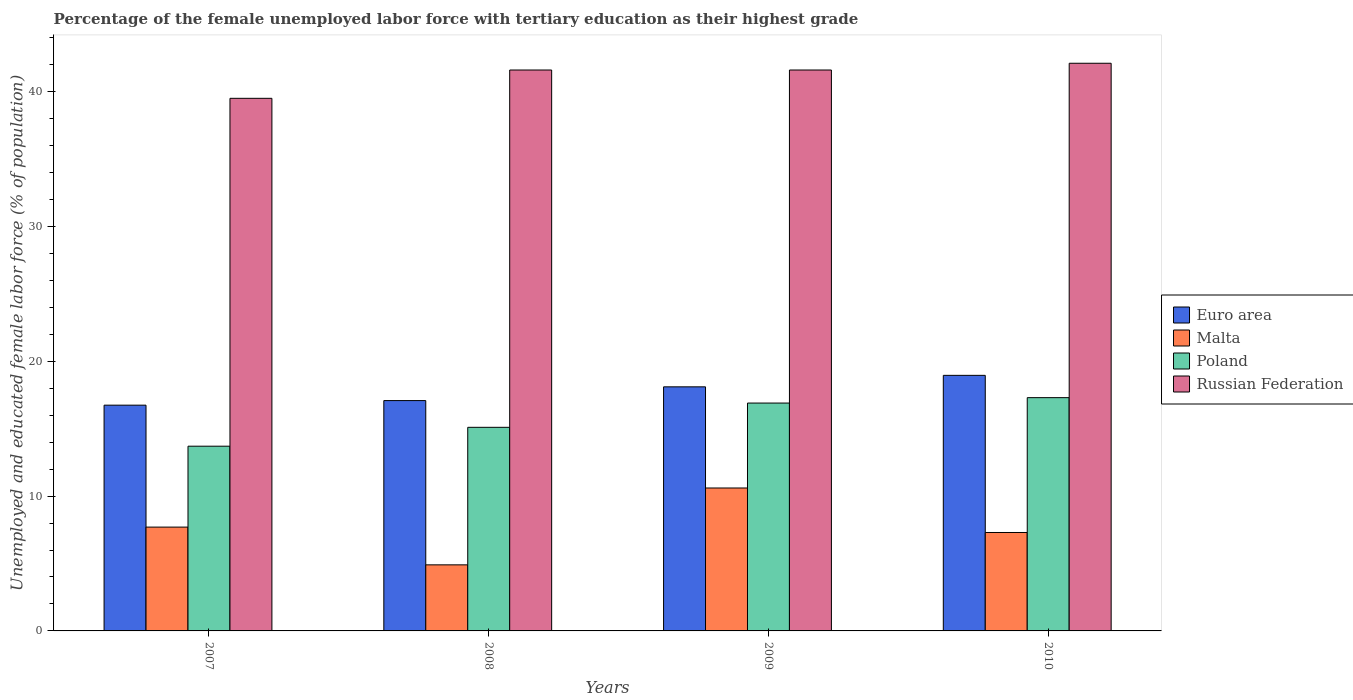How many different coloured bars are there?
Your answer should be very brief. 4. How many groups of bars are there?
Make the answer very short. 4. Are the number of bars per tick equal to the number of legend labels?
Offer a very short reply. Yes. Are the number of bars on each tick of the X-axis equal?
Ensure brevity in your answer.  Yes. What is the label of the 4th group of bars from the left?
Keep it short and to the point. 2010. What is the percentage of the unemployed female labor force with tertiary education in Euro area in 2007?
Offer a terse response. 16.74. Across all years, what is the maximum percentage of the unemployed female labor force with tertiary education in Malta?
Your answer should be very brief. 10.6. Across all years, what is the minimum percentage of the unemployed female labor force with tertiary education in Russian Federation?
Offer a very short reply. 39.5. In which year was the percentage of the unemployed female labor force with tertiary education in Russian Federation maximum?
Give a very brief answer. 2010. In which year was the percentage of the unemployed female labor force with tertiary education in Russian Federation minimum?
Make the answer very short. 2007. What is the total percentage of the unemployed female labor force with tertiary education in Russian Federation in the graph?
Your answer should be very brief. 164.8. What is the difference between the percentage of the unemployed female labor force with tertiary education in Malta in 2007 and that in 2010?
Your answer should be very brief. 0.4. What is the difference between the percentage of the unemployed female labor force with tertiary education in Euro area in 2007 and the percentage of the unemployed female labor force with tertiary education in Poland in 2010?
Offer a very short reply. -0.56. What is the average percentage of the unemployed female labor force with tertiary education in Malta per year?
Your answer should be compact. 7.63. In the year 2010, what is the difference between the percentage of the unemployed female labor force with tertiary education in Poland and percentage of the unemployed female labor force with tertiary education in Russian Federation?
Your response must be concise. -24.8. In how many years, is the percentage of the unemployed female labor force with tertiary education in Malta greater than 42 %?
Provide a succinct answer. 0. What is the ratio of the percentage of the unemployed female labor force with tertiary education in Russian Federation in 2009 to that in 2010?
Offer a very short reply. 0.99. What is the difference between the highest and the second highest percentage of the unemployed female labor force with tertiary education in Poland?
Your answer should be very brief. 0.4. What is the difference between the highest and the lowest percentage of the unemployed female labor force with tertiary education in Euro area?
Ensure brevity in your answer.  2.21. Is it the case that in every year, the sum of the percentage of the unemployed female labor force with tertiary education in Malta and percentage of the unemployed female labor force with tertiary education in Euro area is greater than the sum of percentage of the unemployed female labor force with tertiary education in Poland and percentage of the unemployed female labor force with tertiary education in Russian Federation?
Provide a short and direct response. No. What does the 3rd bar from the left in 2009 represents?
Your answer should be compact. Poland. What does the 3rd bar from the right in 2009 represents?
Keep it short and to the point. Malta. Is it the case that in every year, the sum of the percentage of the unemployed female labor force with tertiary education in Poland and percentage of the unemployed female labor force with tertiary education in Euro area is greater than the percentage of the unemployed female labor force with tertiary education in Malta?
Make the answer very short. Yes. How many bars are there?
Your response must be concise. 16. How many years are there in the graph?
Your answer should be compact. 4. Does the graph contain any zero values?
Make the answer very short. No. How many legend labels are there?
Your answer should be very brief. 4. What is the title of the graph?
Your response must be concise. Percentage of the female unemployed labor force with tertiary education as their highest grade. What is the label or title of the Y-axis?
Provide a short and direct response. Unemployed and educated female labor force (% of population). What is the Unemployed and educated female labor force (% of population) in Euro area in 2007?
Ensure brevity in your answer.  16.74. What is the Unemployed and educated female labor force (% of population) in Malta in 2007?
Provide a short and direct response. 7.7. What is the Unemployed and educated female labor force (% of population) of Poland in 2007?
Keep it short and to the point. 13.7. What is the Unemployed and educated female labor force (% of population) in Russian Federation in 2007?
Offer a very short reply. 39.5. What is the Unemployed and educated female labor force (% of population) in Euro area in 2008?
Your response must be concise. 17.08. What is the Unemployed and educated female labor force (% of population) in Malta in 2008?
Offer a terse response. 4.9. What is the Unemployed and educated female labor force (% of population) of Poland in 2008?
Keep it short and to the point. 15.1. What is the Unemployed and educated female labor force (% of population) in Russian Federation in 2008?
Your response must be concise. 41.6. What is the Unemployed and educated female labor force (% of population) in Euro area in 2009?
Your answer should be very brief. 18.1. What is the Unemployed and educated female labor force (% of population) in Malta in 2009?
Your answer should be very brief. 10.6. What is the Unemployed and educated female labor force (% of population) of Poland in 2009?
Your answer should be very brief. 16.9. What is the Unemployed and educated female labor force (% of population) in Russian Federation in 2009?
Provide a short and direct response. 41.6. What is the Unemployed and educated female labor force (% of population) in Euro area in 2010?
Offer a very short reply. 18.95. What is the Unemployed and educated female labor force (% of population) in Malta in 2010?
Ensure brevity in your answer.  7.3. What is the Unemployed and educated female labor force (% of population) of Poland in 2010?
Provide a succinct answer. 17.3. What is the Unemployed and educated female labor force (% of population) of Russian Federation in 2010?
Ensure brevity in your answer.  42.1. Across all years, what is the maximum Unemployed and educated female labor force (% of population) in Euro area?
Keep it short and to the point. 18.95. Across all years, what is the maximum Unemployed and educated female labor force (% of population) in Malta?
Provide a short and direct response. 10.6. Across all years, what is the maximum Unemployed and educated female labor force (% of population) of Poland?
Your answer should be very brief. 17.3. Across all years, what is the maximum Unemployed and educated female labor force (% of population) in Russian Federation?
Your response must be concise. 42.1. Across all years, what is the minimum Unemployed and educated female labor force (% of population) in Euro area?
Your answer should be compact. 16.74. Across all years, what is the minimum Unemployed and educated female labor force (% of population) in Malta?
Provide a short and direct response. 4.9. Across all years, what is the minimum Unemployed and educated female labor force (% of population) in Poland?
Provide a short and direct response. 13.7. Across all years, what is the minimum Unemployed and educated female labor force (% of population) in Russian Federation?
Your answer should be very brief. 39.5. What is the total Unemployed and educated female labor force (% of population) of Euro area in the graph?
Provide a succinct answer. 70.88. What is the total Unemployed and educated female labor force (% of population) in Malta in the graph?
Ensure brevity in your answer.  30.5. What is the total Unemployed and educated female labor force (% of population) in Poland in the graph?
Your answer should be very brief. 63. What is the total Unemployed and educated female labor force (% of population) of Russian Federation in the graph?
Provide a short and direct response. 164.8. What is the difference between the Unemployed and educated female labor force (% of population) of Euro area in 2007 and that in 2008?
Your response must be concise. -0.34. What is the difference between the Unemployed and educated female labor force (% of population) of Poland in 2007 and that in 2008?
Your response must be concise. -1.4. What is the difference between the Unemployed and educated female labor force (% of population) of Russian Federation in 2007 and that in 2008?
Your response must be concise. -2.1. What is the difference between the Unemployed and educated female labor force (% of population) of Euro area in 2007 and that in 2009?
Ensure brevity in your answer.  -1.36. What is the difference between the Unemployed and educated female labor force (% of population) in Poland in 2007 and that in 2009?
Give a very brief answer. -3.2. What is the difference between the Unemployed and educated female labor force (% of population) in Euro area in 2007 and that in 2010?
Offer a very short reply. -2.21. What is the difference between the Unemployed and educated female labor force (% of population) in Russian Federation in 2007 and that in 2010?
Ensure brevity in your answer.  -2.6. What is the difference between the Unemployed and educated female labor force (% of population) in Euro area in 2008 and that in 2009?
Provide a short and direct response. -1.02. What is the difference between the Unemployed and educated female labor force (% of population) in Malta in 2008 and that in 2009?
Your answer should be very brief. -5.7. What is the difference between the Unemployed and educated female labor force (% of population) of Poland in 2008 and that in 2009?
Your answer should be compact. -1.8. What is the difference between the Unemployed and educated female labor force (% of population) of Euro area in 2008 and that in 2010?
Keep it short and to the point. -1.87. What is the difference between the Unemployed and educated female labor force (% of population) of Malta in 2008 and that in 2010?
Give a very brief answer. -2.4. What is the difference between the Unemployed and educated female labor force (% of population) of Poland in 2008 and that in 2010?
Your response must be concise. -2.2. What is the difference between the Unemployed and educated female labor force (% of population) of Euro area in 2009 and that in 2010?
Give a very brief answer. -0.85. What is the difference between the Unemployed and educated female labor force (% of population) in Poland in 2009 and that in 2010?
Your response must be concise. -0.4. What is the difference between the Unemployed and educated female labor force (% of population) in Euro area in 2007 and the Unemployed and educated female labor force (% of population) in Malta in 2008?
Provide a short and direct response. 11.84. What is the difference between the Unemployed and educated female labor force (% of population) in Euro area in 2007 and the Unemployed and educated female labor force (% of population) in Poland in 2008?
Your answer should be compact. 1.64. What is the difference between the Unemployed and educated female labor force (% of population) of Euro area in 2007 and the Unemployed and educated female labor force (% of population) of Russian Federation in 2008?
Keep it short and to the point. -24.86. What is the difference between the Unemployed and educated female labor force (% of population) of Malta in 2007 and the Unemployed and educated female labor force (% of population) of Russian Federation in 2008?
Provide a succinct answer. -33.9. What is the difference between the Unemployed and educated female labor force (% of population) of Poland in 2007 and the Unemployed and educated female labor force (% of population) of Russian Federation in 2008?
Provide a short and direct response. -27.9. What is the difference between the Unemployed and educated female labor force (% of population) in Euro area in 2007 and the Unemployed and educated female labor force (% of population) in Malta in 2009?
Provide a short and direct response. 6.14. What is the difference between the Unemployed and educated female labor force (% of population) in Euro area in 2007 and the Unemployed and educated female labor force (% of population) in Poland in 2009?
Offer a very short reply. -0.16. What is the difference between the Unemployed and educated female labor force (% of population) in Euro area in 2007 and the Unemployed and educated female labor force (% of population) in Russian Federation in 2009?
Offer a terse response. -24.86. What is the difference between the Unemployed and educated female labor force (% of population) of Malta in 2007 and the Unemployed and educated female labor force (% of population) of Russian Federation in 2009?
Make the answer very short. -33.9. What is the difference between the Unemployed and educated female labor force (% of population) of Poland in 2007 and the Unemployed and educated female labor force (% of population) of Russian Federation in 2009?
Your response must be concise. -27.9. What is the difference between the Unemployed and educated female labor force (% of population) of Euro area in 2007 and the Unemployed and educated female labor force (% of population) of Malta in 2010?
Offer a terse response. 9.44. What is the difference between the Unemployed and educated female labor force (% of population) of Euro area in 2007 and the Unemployed and educated female labor force (% of population) of Poland in 2010?
Ensure brevity in your answer.  -0.56. What is the difference between the Unemployed and educated female labor force (% of population) of Euro area in 2007 and the Unemployed and educated female labor force (% of population) of Russian Federation in 2010?
Provide a short and direct response. -25.36. What is the difference between the Unemployed and educated female labor force (% of population) of Malta in 2007 and the Unemployed and educated female labor force (% of population) of Poland in 2010?
Make the answer very short. -9.6. What is the difference between the Unemployed and educated female labor force (% of population) in Malta in 2007 and the Unemployed and educated female labor force (% of population) in Russian Federation in 2010?
Your answer should be compact. -34.4. What is the difference between the Unemployed and educated female labor force (% of population) in Poland in 2007 and the Unemployed and educated female labor force (% of population) in Russian Federation in 2010?
Keep it short and to the point. -28.4. What is the difference between the Unemployed and educated female labor force (% of population) of Euro area in 2008 and the Unemployed and educated female labor force (% of population) of Malta in 2009?
Ensure brevity in your answer.  6.48. What is the difference between the Unemployed and educated female labor force (% of population) of Euro area in 2008 and the Unemployed and educated female labor force (% of population) of Poland in 2009?
Offer a very short reply. 0.18. What is the difference between the Unemployed and educated female labor force (% of population) in Euro area in 2008 and the Unemployed and educated female labor force (% of population) in Russian Federation in 2009?
Your answer should be compact. -24.52. What is the difference between the Unemployed and educated female labor force (% of population) of Malta in 2008 and the Unemployed and educated female labor force (% of population) of Poland in 2009?
Ensure brevity in your answer.  -12. What is the difference between the Unemployed and educated female labor force (% of population) of Malta in 2008 and the Unemployed and educated female labor force (% of population) of Russian Federation in 2009?
Your answer should be very brief. -36.7. What is the difference between the Unemployed and educated female labor force (% of population) in Poland in 2008 and the Unemployed and educated female labor force (% of population) in Russian Federation in 2009?
Ensure brevity in your answer.  -26.5. What is the difference between the Unemployed and educated female labor force (% of population) of Euro area in 2008 and the Unemployed and educated female labor force (% of population) of Malta in 2010?
Your response must be concise. 9.78. What is the difference between the Unemployed and educated female labor force (% of population) in Euro area in 2008 and the Unemployed and educated female labor force (% of population) in Poland in 2010?
Keep it short and to the point. -0.22. What is the difference between the Unemployed and educated female labor force (% of population) in Euro area in 2008 and the Unemployed and educated female labor force (% of population) in Russian Federation in 2010?
Your answer should be compact. -25.02. What is the difference between the Unemployed and educated female labor force (% of population) of Malta in 2008 and the Unemployed and educated female labor force (% of population) of Poland in 2010?
Offer a very short reply. -12.4. What is the difference between the Unemployed and educated female labor force (% of population) in Malta in 2008 and the Unemployed and educated female labor force (% of population) in Russian Federation in 2010?
Your answer should be compact. -37.2. What is the difference between the Unemployed and educated female labor force (% of population) of Euro area in 2009 and the Unemployed and educated female labor force (% of population) of Malta in 2010?
Provide a short and direct response. 10.8. What is the difference between the Unemployed and educated female labor force (% of population) in Euro area in 2009 and the Unemployed and educated female labor force (% of population) in Poland in 2010?
Your answer should be very brief. 0.8. What is the difference between the Unemployed and educated female labor force (% of population) of Euro area in 2009 and the Unemployed and educated female labor force (% of population) of Russian Federation in 2010?
Make the answer very short. -24. What is the difference between the Unemployed and educated female labor force (% of population) in Malta in 2009 and the Unemployed and educated female labor force (% of population) in Poland in 2010?
Keep it short and to the point. -6.7. What is the difference between the Unemployed and educated female labor force (% of population) in Malta in 2009 and the Unemployed and educated female labor force (% of population) in Russian Federation in 2010?
Your response must be concise. -31.5. What is the difference between the Unemployed and educated female labor force (% of population) in Poland in 2009 and the Unemployed and educated female labor force (% of population) in Russian Federation in 2010?
Provide a succinct answer. -25.2. What is the average Unemployed and educated female labor force (% of population) of Euro area per year?
Provide a succinct answer. 17.72. What is the average Unemployed and educated female labor force (% of population) in Malta per year?
Offer a very short reply. 7.62. What is the average Unemployed and educated female labor force (% of population) of Poland per year?
Your answer should be very brief. 15.75. What is the average Unemployed and educated female labor force (% of population) of Russian Federation per year?
Your answer should be very brief. 41.2. In the year 2007, what is the difference between the Unemployed and educated female labor force (% of population) in Euro area and Unemployed and educated female labor force (% of population) in Malta?
Provide a succinct answer. 9.04. In the year 2007, what is the difference between the Unemployed and educated female labor force (% of population) of Euro area and Unemployed and educated female labor force (% of population) of Poland?
Ensure brevity in your answer.  3.04. In the year 2007, what is the difference between the Unemployed and educated female labor force (% of population) in Euro area and Unemployed and educated female labor force (% of population) in Russian Federation?
Ensure brevity in your answer.  -22.76. In the year 2007, what is the difference between the Unemployed and educated female labor force (% of population) in Malta and Unemployed and educated female labor force (% of population) in Poland?
Your answer should be compact. -6. In the year 2007, what is the difference between the Unemployed and educated female labor force (% of population) in Malta and Unemployed and educated female labor force (% of population) in Russian Federation?
Offer a very short reply. -31.8. In the year 2007, what is the difference between the Unemployed and educated female labor force (% of population) of Poland and Unemployed and educated female labor force (% of population) of Russian Federation?
Make the answer very short. -25.8. In the year 2008, what is the difference between the Unemployed and educated female labor force (% of population) in Euro area and Unemployed and educated female labor force (% of population) in Malta?
Keep it short and to the point. 12.18. In the year 2008, what is the difference between the Unemployed and educated female labor force (% of population) in Euro area and Unemployed and educated female labor force (% of population) in Poland?
Your answer should be compact. 1.98. In the year 2008, what is the difference between the Unemployed and educated female labor force (% of population) of Euro area and Unemployed and educated female labor force (% of population) of Russian Federation?
Your answer should be compact. -24.52. In the year 2008, what is the difference between the Unemployed and educated female labor force (% of population) in Malta and Unemployed and educated female labor force (% of population) in Poland?
Make the answer very short. -10.2. In the year 2008, what is the difference between the Unemployed and educated female labor force (% of population) of Malta and Unemployed and educated female labor force (% of population) of Russian Federation?
Your answer should be compact. -36.7. In the year 2008, what is the difference between the Unemployed and educated female labor force (% of population) in Poland and Unemployed and educated female labor force (% of population) in Russian Federation?
Your answer should be compact. -26.5. In the year 2009, what is the difference between the Unemployed and educated female labor force (% of population) of Euro area and Unemployed and educated female labor force (% of population) of Malta?
Give a very brief answer. 7.5. In the year 2009, what is the difference between the Unemployed and educated female labor force (% of population) of Euro area and Unemployed and educated female labor force (% of population) of Poland?
Offer a very short reply. 1.2. In the year 2009, what is the difference between the Unemployed and educated female labor force (% of population) of Euro area and Unemployed and educated female labor force (% of population) of Russian Federation?
Your response must be concise. -23.5. In the year 2009, what is the difference between the Unemployed and educated female labor force (% of population) of Malta and Unemployed and educated female labor force (% of population) of Poland?
Provide a short and direct response. -6.3. In the year 2009, what is the difference between the Unemployed and educated female labor force (% of population) of Malta and Unemployed and educated female labor force (% of population) of Russian Federation?
Your answer should be compact. -31. In the year 2009, what is the difference between the Unemployed and educated female labor force (% of population) in Poland and Unemployed and educated female labor force (% of population) in Russian Federation?
Make the answer very short. -24.7. In the year 2010, what is the difference between the Unemployed and educated female labor force (% of population) of Euro area and Unemployed and educated female labor force (% of population) of Malta?
Offer a very short reply. 11.65. In the year 2010, what is the difference between the Unemployed and educated female labor force (% of population) of Euro area and Unemployed and educated female labor force (% of population) of Poland?
Your response must be concise. 1.65. In the year 2010, what is the difference between the Unemployed and educated female labor force (% of population) of Euro area and Unemployed and educated female labor force (% of population) of Russian Federation?
Your response must be concise. -23.15. In the year 2010, what is the difference between the Unemployed and educated female labor force (% of population) in Malta and Unemployed and educated female labor force (% of population) in Russian Federation?
Provide a short and direct response. -34.8. In the year 2010, what is the difference between the Unemployed and educated female labor force (% of population) of Poland and Unemployed and educated female labor force (% of population) of Russian Federation?
Provide a succinct answer. -24.8. What is the ratio of the Unemployed and educated female labor force (% of population) of Euro area in 2007 to that in 2008?
Offer a very short reply. 0.98. What is the ratio of the Unemployed and educated female labor force (% of population) in Malta in 2007 to that in 2008?
Your answer should be compact. 1.57. What is the ratio of the Unemployed and educated female labor force (% of population) in Poland in 2007 to that in 2008?
Provide a short and direct response. 0.91. What is the ratio of the Unemployed and educated female labor force (% of population) of Russian Federation in 2007 to that in 2008?
Make the answer very short. 0.95. What is the ratio of the Unemployed and educated female labor force (% of population) in Euro area in 2007 to that in 2009?
Keep it short and to the point. 0.92. What is the ratio of the Unemployed and educated female labor force (% of population) in Malta in 2007 to that in 2009?
Your answer should be compact. 0.73. What is the ratio of the Unemployed and educated female labor force (% of population) in Poland in 2007 to that in 2009?
Keep it short and to the point. 0.81. What is the ratio of the Unemployed and educated female labor force (% of population) of Russian Federation in 2007 to that in 2009?
Your response must be concise. 0.95. What is the ratio of the Unemployed and educated female labor force (% of population) of Euro area in 2007 to that in 2010?
Ensure brevity in your answer.  0.88. What is the ratio of the Unemployed and educated female labor force (% of population) of Malta in 2007 to that in 2010?
Your answer should be compact. 1.05. What is the ratio of the Unemployed and educated female labor force (% of population) in Poland in 2007 to that in 2010?
Provide a short and direct response. 0.79. What is the ratio of the Unemployed and educated female labor force (% of population) in Russian Federation in 2007 to that in 2010?
Offer a terse response. 0.94. What is the ratio of the Unemployed and educated female labor force (% of population) in Euro area in 2008 to that in 2009?
Offer a very short reply. 0.94. What is the ratio of the Unemployed and educated female labor force (% of population) in Malta in 2008 to that in 2009?
Your answer should be very brief. 0.46. What is the ratio of the Unemployed and educated female labor force (% of population) in Poland in 2008 to that in 2009?
Ensure brevity in your answer.  0.89. What is the ratio of the Unemployed and educated female labor force (% of population) in Russian Federation in 2008 to that in 2009?
Your answer should be compact. 1. What is the ratio of the Unemployed and educated female labor force (% of population) in Euro area in 2008 to that in 2010?
Provide a short and direct response. 0.9. What is the ratio of the Unemployed and educated female labor force (% of population) of Malta in 2008 to that in 2010?
Ensure brevity in your answer.  0.67. What is the ratio of the Unemployed and educated female labor force (% of population) of Poland in 2008 to that in 2010?
Ensure brevity in your answer.  0.87. What is the ratio of the Unemployed and educated female labor force (% of population) of Euro area in 2009 to that in 2010?
Provide a succinct answer. 0.96. What is the ratio of the Unemployed and educated female labor force (% of population) in Malta in 2009 to that in 2010?
Keep it short and to the point. 1.45. What is the ratio of the Unemployed and educated female labor force (% of population) in Poland in 2009 to that in 2010?
Offer a terse response. 0.98. What is the difference between the highest and the second highest Unemployed and educated female labor force (% of population) of Euro area?
Offer a very short reply. 0.85. What is the difference between the highest and the lowest Unemployed and educated female labor force (% of population) in Euro area?
Offer a terse response. 2.21. What is the difference between the highest and the lowest Unemployed and educated female labor force (% of population) in Malta?
Offer a terse response. 5.7. What is the difference between the highest and the lowest Unemployed and educated female labor force (% of population) of Russian Federation?
Keep it short and to the point. 2.6. 